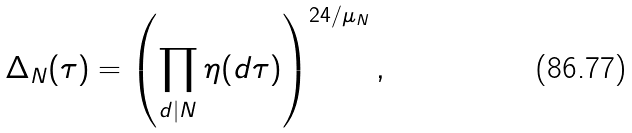Convert formula to latex. <formula><loc_0><loc_0><loc_500><loc_500>\Delta _ { N } ( \tau ) = \left ( \prod _ { d | N } \eta ( d \tau ) \right ) ^ { 2 4 / \mu _ { N } } ,</formula> 